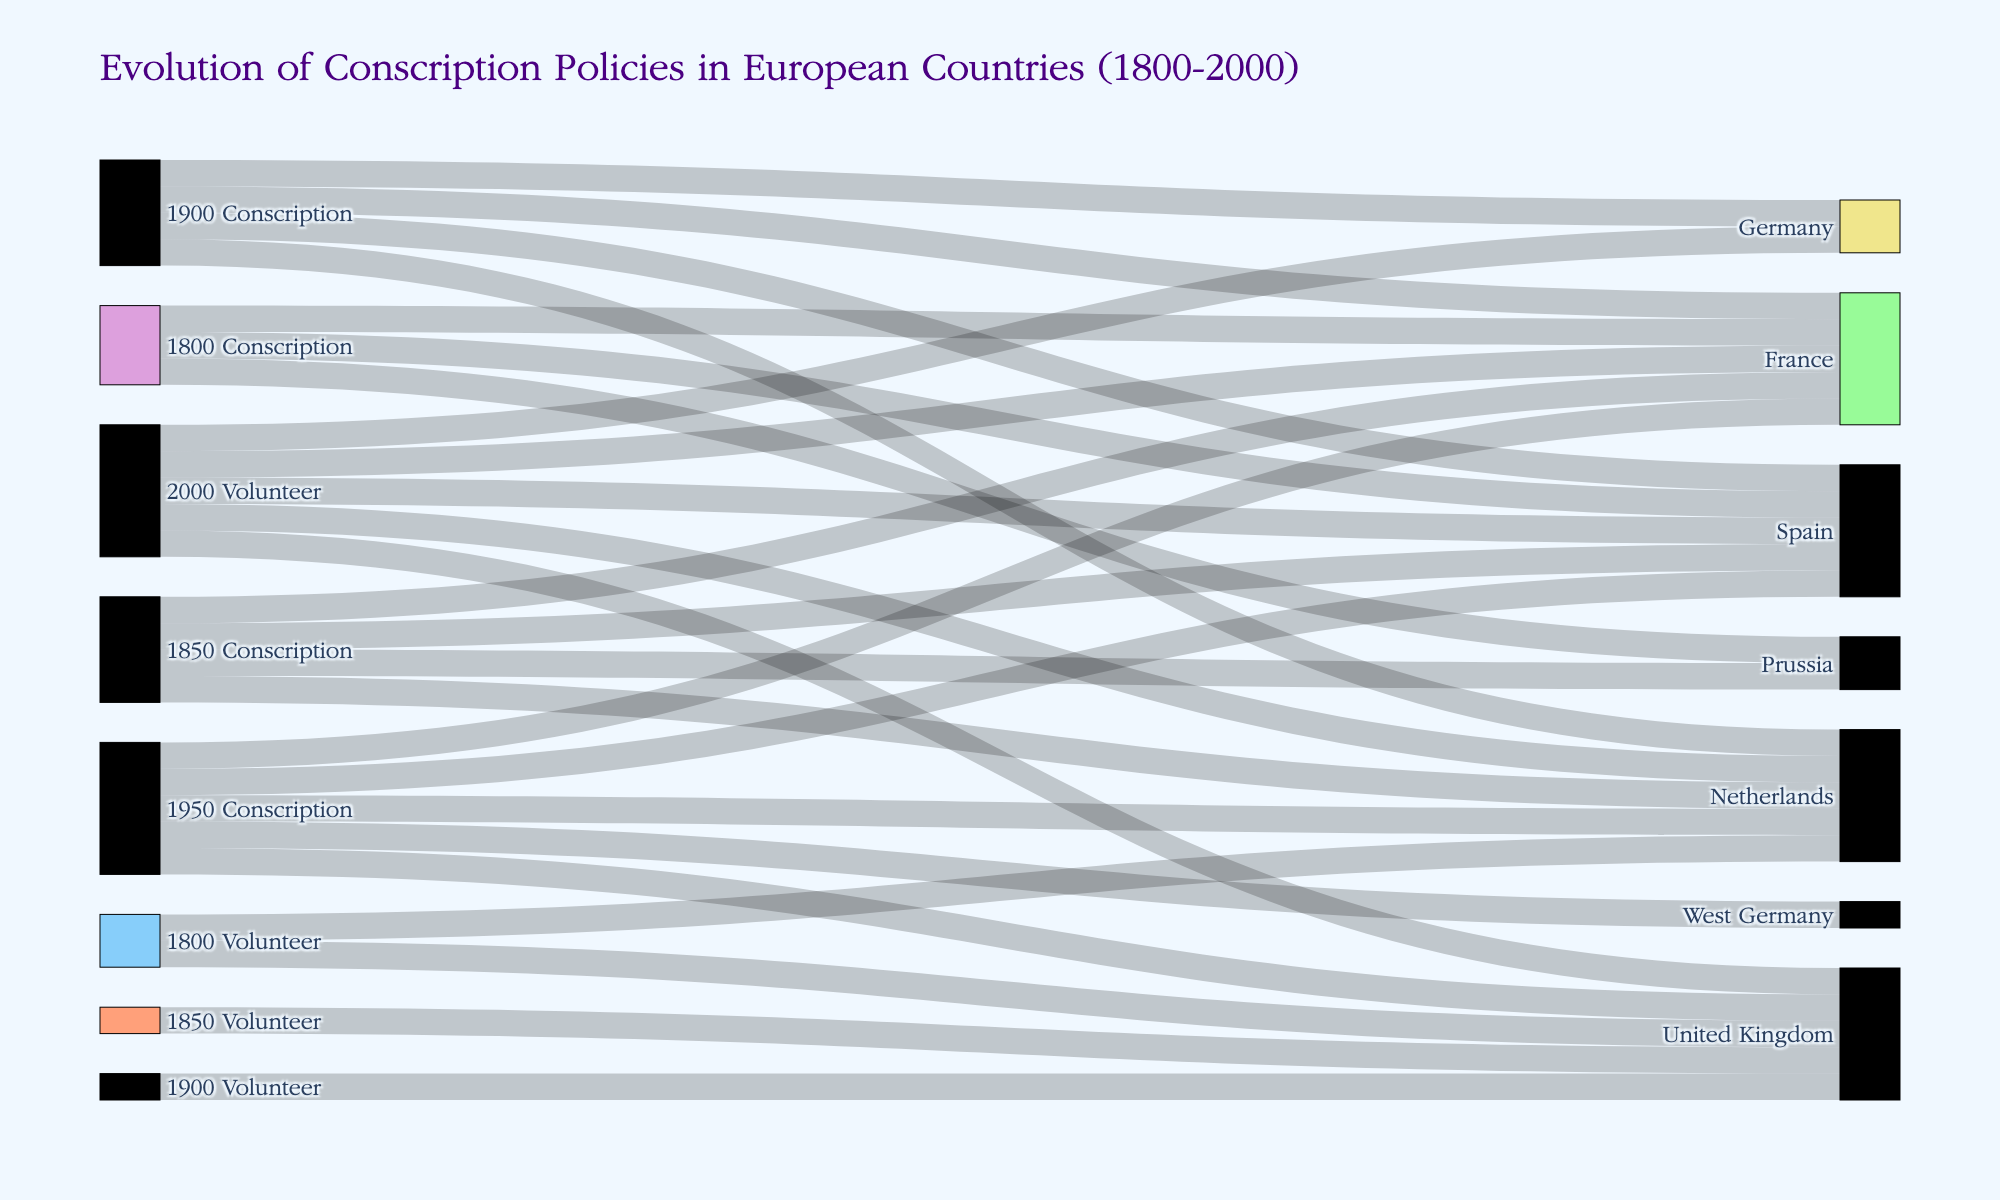What is the title of the figure? The title is usually found at the top of the diagram. In this case, it’s clearly indicated as "Evolution of Conscription Policies in European Countries (1800-2000)".
Answer: Evolution of Conscription Policies in European Countries (1800-2000) How does the conscription status of Spain change from 1800 to 2000? By following the flows labeled with "Spain" from left (1800) to right (2000), it can be observed that Spain starts with conscription policies in 1800 and shifts to volunteer service by 2000.
Answer: From conscription to volunteer Which countries had mandatory conscription throughout the 1800s? Reviewing the left section of the diagram for the 1800s, we observe the countries connected to "1800 Conscription" and "1850 Conscription". France, Prussia, and Spain had conscription policies in both years.
Answer: France, Prussia, Spain How many countries had volunteer service in 2000? By finding "2000 Volunteer" and counting the unique outgoing connections from this node, we notice five connections indicating five countries had volunteer service in 2000.
Answer: Five What pattern do we see regarding the conscription status of France from 1900 to 2000? Observing France's connections, it had conscription in 1900 and 1950, but shifted to volunteer service by 2000. This shows a transition from conscription to volunteer within the century.
Answer: Shift from conscription to volunteer How many countries switched from conscription to volunteer service between 1950 and 2000? By looking at the connections from "1950 Conscription" to "2000 Volunteer", we see France, Germany, Spain, Netherlands, and United Kingdom, totaling five countries.
Answer: Five Compare the conscription policies of the United Kingdom from 1800 to 2000. Analyzing the connections, the United Kingdom initially had a volunteer-based service in 1800, maintained this in 1850, adopted conscription by 1950, and reverted to volunteer service by 2000.
Answer: Switched between volunteer and conscription twice How does the conscription policy of the Netherlands evolve over time? Tracing the flow of the Netherlands, it starts with volunteer service in 1800, moves to conscription in 1850, 1900, and 1950, but finally shifts to volunteer service by 2000.
Answer: From volunteer to conscription, then volunteer again Which country had a consistent volunteer service from 1800 to 1900? Observing the connections from "1800 Volunteer" and "1900 Volunteer," only the United Kingdom had volunteer service in both periods.
Answer: United Kingdom 